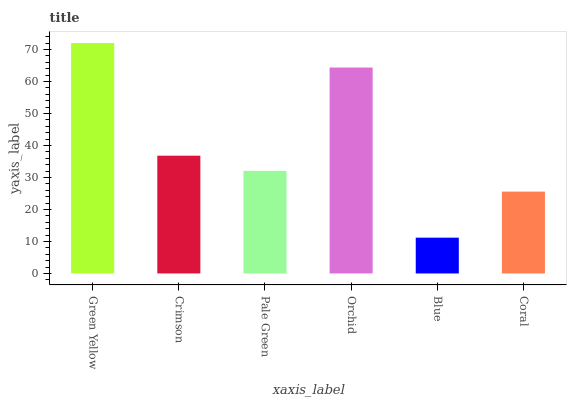Is Blue the minimum?
Answer yes or no. Yes. Is Green Yellow the maximum?
Answer yes or no. Yes. Is Crimson the minimum?
Answer yes or no. No. Is Crimson the maximum?
Answer yes or no. No. Is Green Yellow greater than Crimson?
Answer yes or no. Yes. Is Crimson less than Green Yellow?
Answer yes or no. Yes. Is Crimson greater than Green Yellow?
Answer yes or no. No. Is Green Yellow less than Crimson?
Answer yes or no. No. Is Crimson the high median?
Answer yes or no. Yes. Is Pale Green the low median?
Answer yes or no. Yes. Is Pale Green the high median?
Answer yes or no. No. Is Blue the low median?
Answer yes or no. No. 